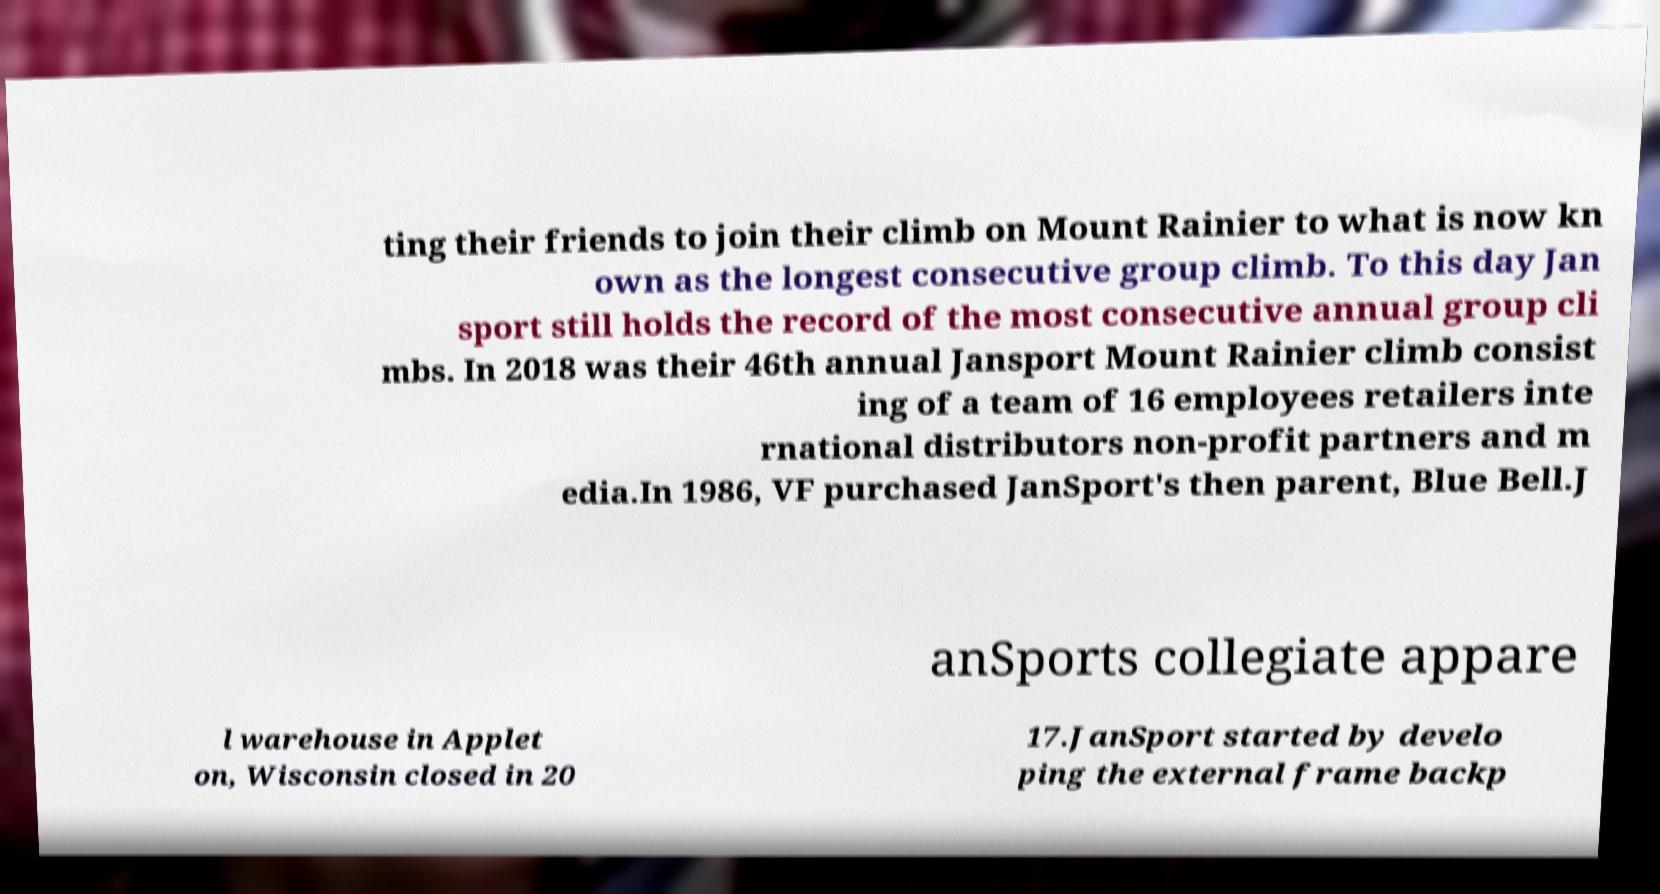There's text embedded in this image that I need extracted. Can you transcribe it verbatim? ting their friends to join their climb on Mount Rainier to what is now kn own as the longest consecutive group climb. To this day Jan sport still holds the record of the most consecutive annual group cli mbs. In 2018 was their 46th annual Jansport Mount Rainier climb consist ing of a team of 16 employees retailers inte rnational distributors non-profit partners and m edia.In 1986, VF purchased JanSport's then parent, Blue Bell.J anSports collegiate appare l warehouse in Applet on, Wisconsin closed in 20 17.JanSport started by develo ping the external frame backp 